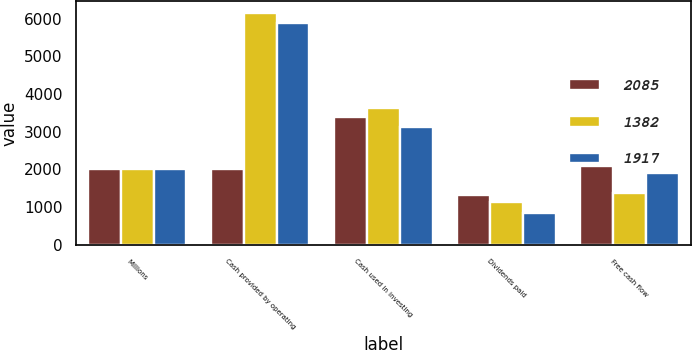<chart> <loc_0><loc_0><loc_500><loc_500><stacked_bar_chart><ecel><fcel>Millions<fcel>Cash provided by operating<fcel>Cash used in investing<fcel>Dividends paid<fcel>Free cash flow<nl><fcel>2085<fcel>2013<fcel>2012.5<fcel>3405<fcel>1333<fcel>2085<nl><fcel>1382<fcel>2012<fcel>6161<fcel>3633<fcel>1146<fcel>1382<nl><fcel>1917<fcel>2011<fcel>5873<fcel>3119<fcel>837<fcel>1917<nl></chart> 